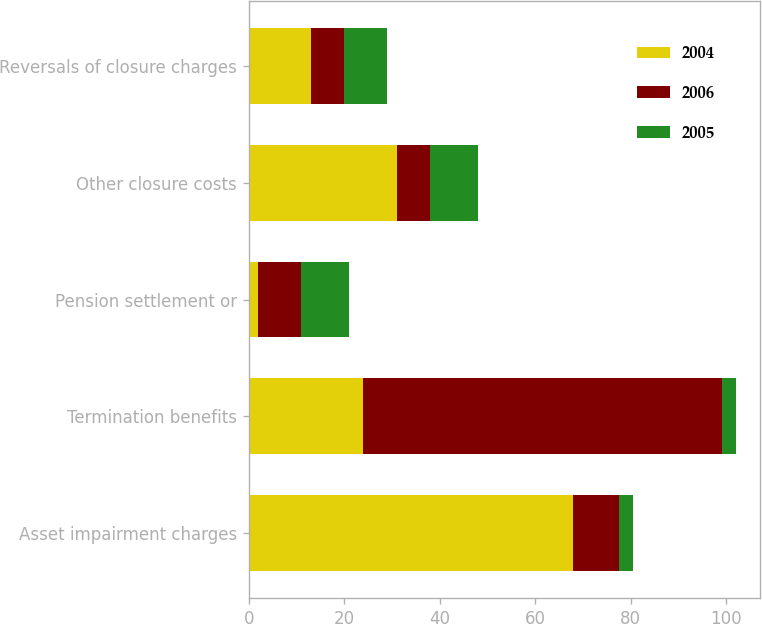Convert chart to OTSL. <chart><loc_0><loc_0><loc_500><loc_500><stacked_bar_chart><ecel><fcel>Asset impairment charges<fcel>Termination benefits<fcel>Pension settlement or<fcel>Other closure costs<fcel>Reversals of closure charges<nl><fcel>2004<fcel>68<fcel>24<fcel>2<fcel>31<fcel>13<nl><fcel>2006<fcel>9.5<fcel>75<fcel>9<fcel>7<fcel>7<nl><fcel>2005<fcel>3<fcel>3<fcel>10<fcel>10<fcel>9<nl></chart> 